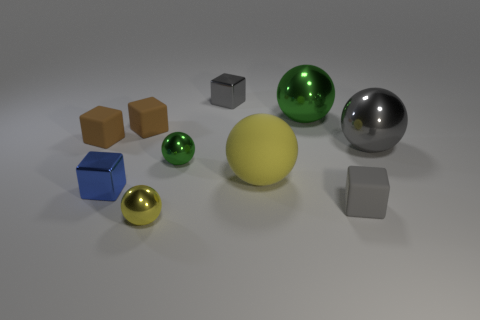What might be the purpose of this collection of objects? This assembly of objects is likely designed to demonstrate rendering techniques. The varied shapes and finishes -- reflective, matte, and metallic -- allow an observer to see how different surfaces interact with light and shadows, which is useful for evaluating rendering software or for educational purposes. 